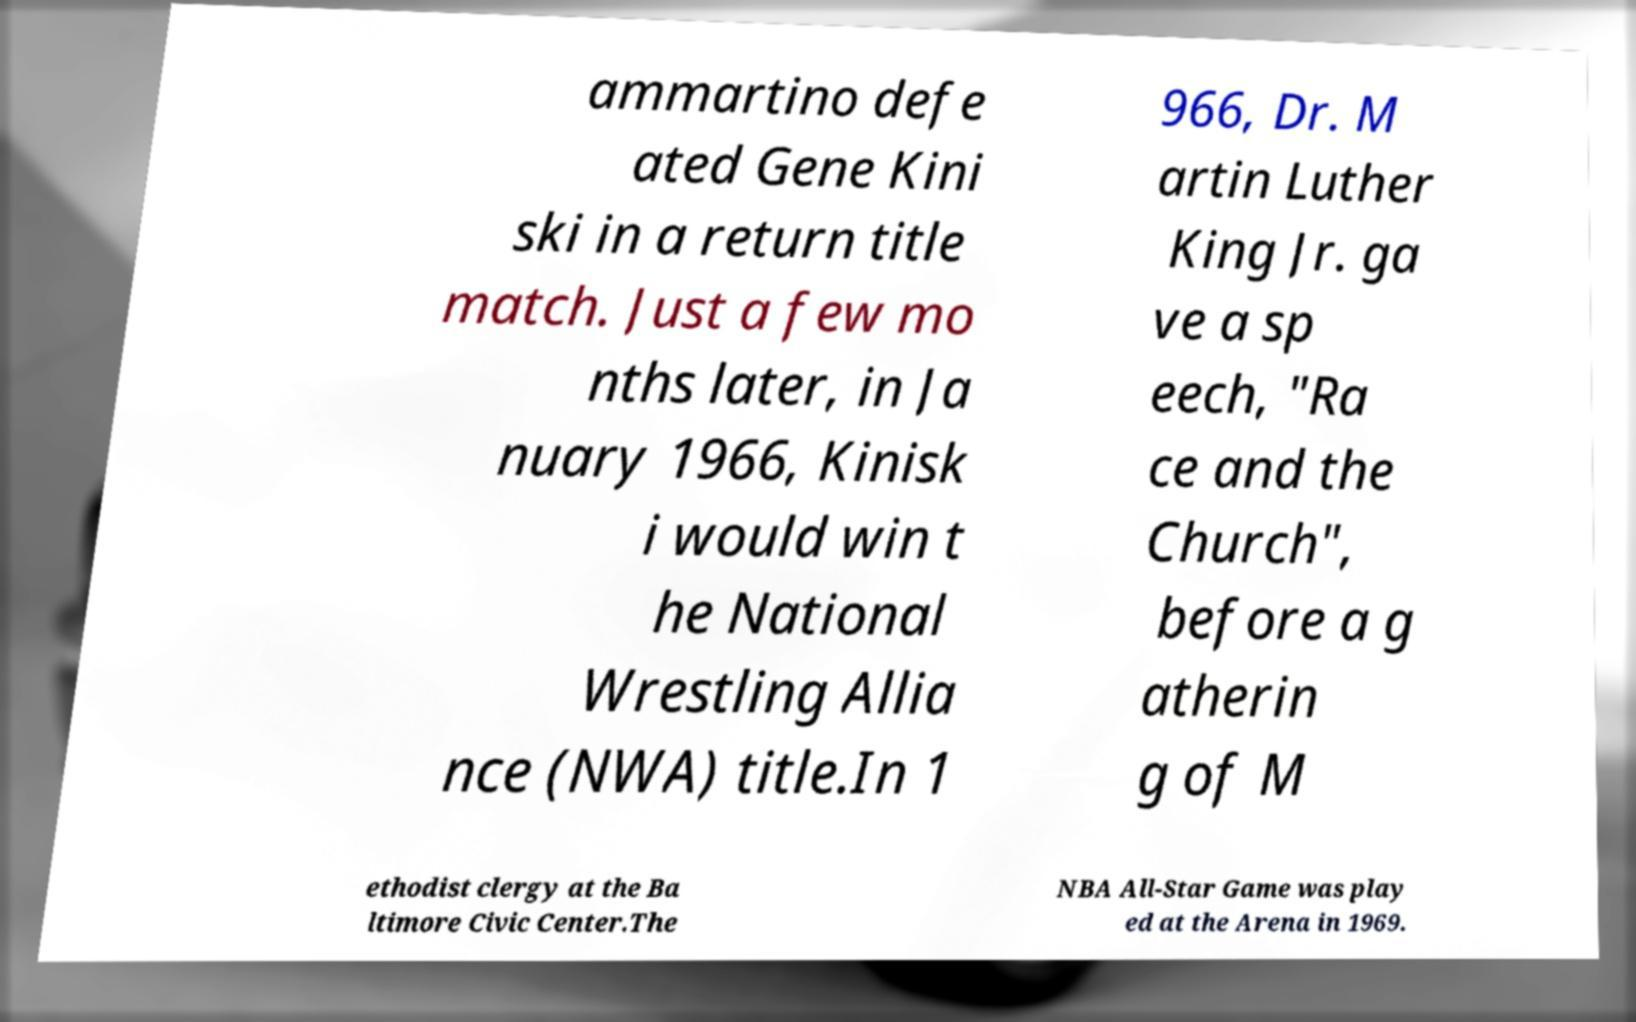Can you read and provide the text displayed in the image?This photo seems to have some interesting text. Can you extract and type it out for me? ammartino defe ated Gene Kini ski in a return title match. Just a few mo nths later, in Ja nuary 1966, Kinisk i would win t he National Wrestling Allia nce (NWA) title.In 1 966, Dr. M artin Luther King Jr. ga ve a sp eech, "Ra ce and the Church", before a g atherin g of M ethodist clergy at the Ba ltimore Civic Center.The NBA All-Star Game was play ed at the Arena in 1969. 